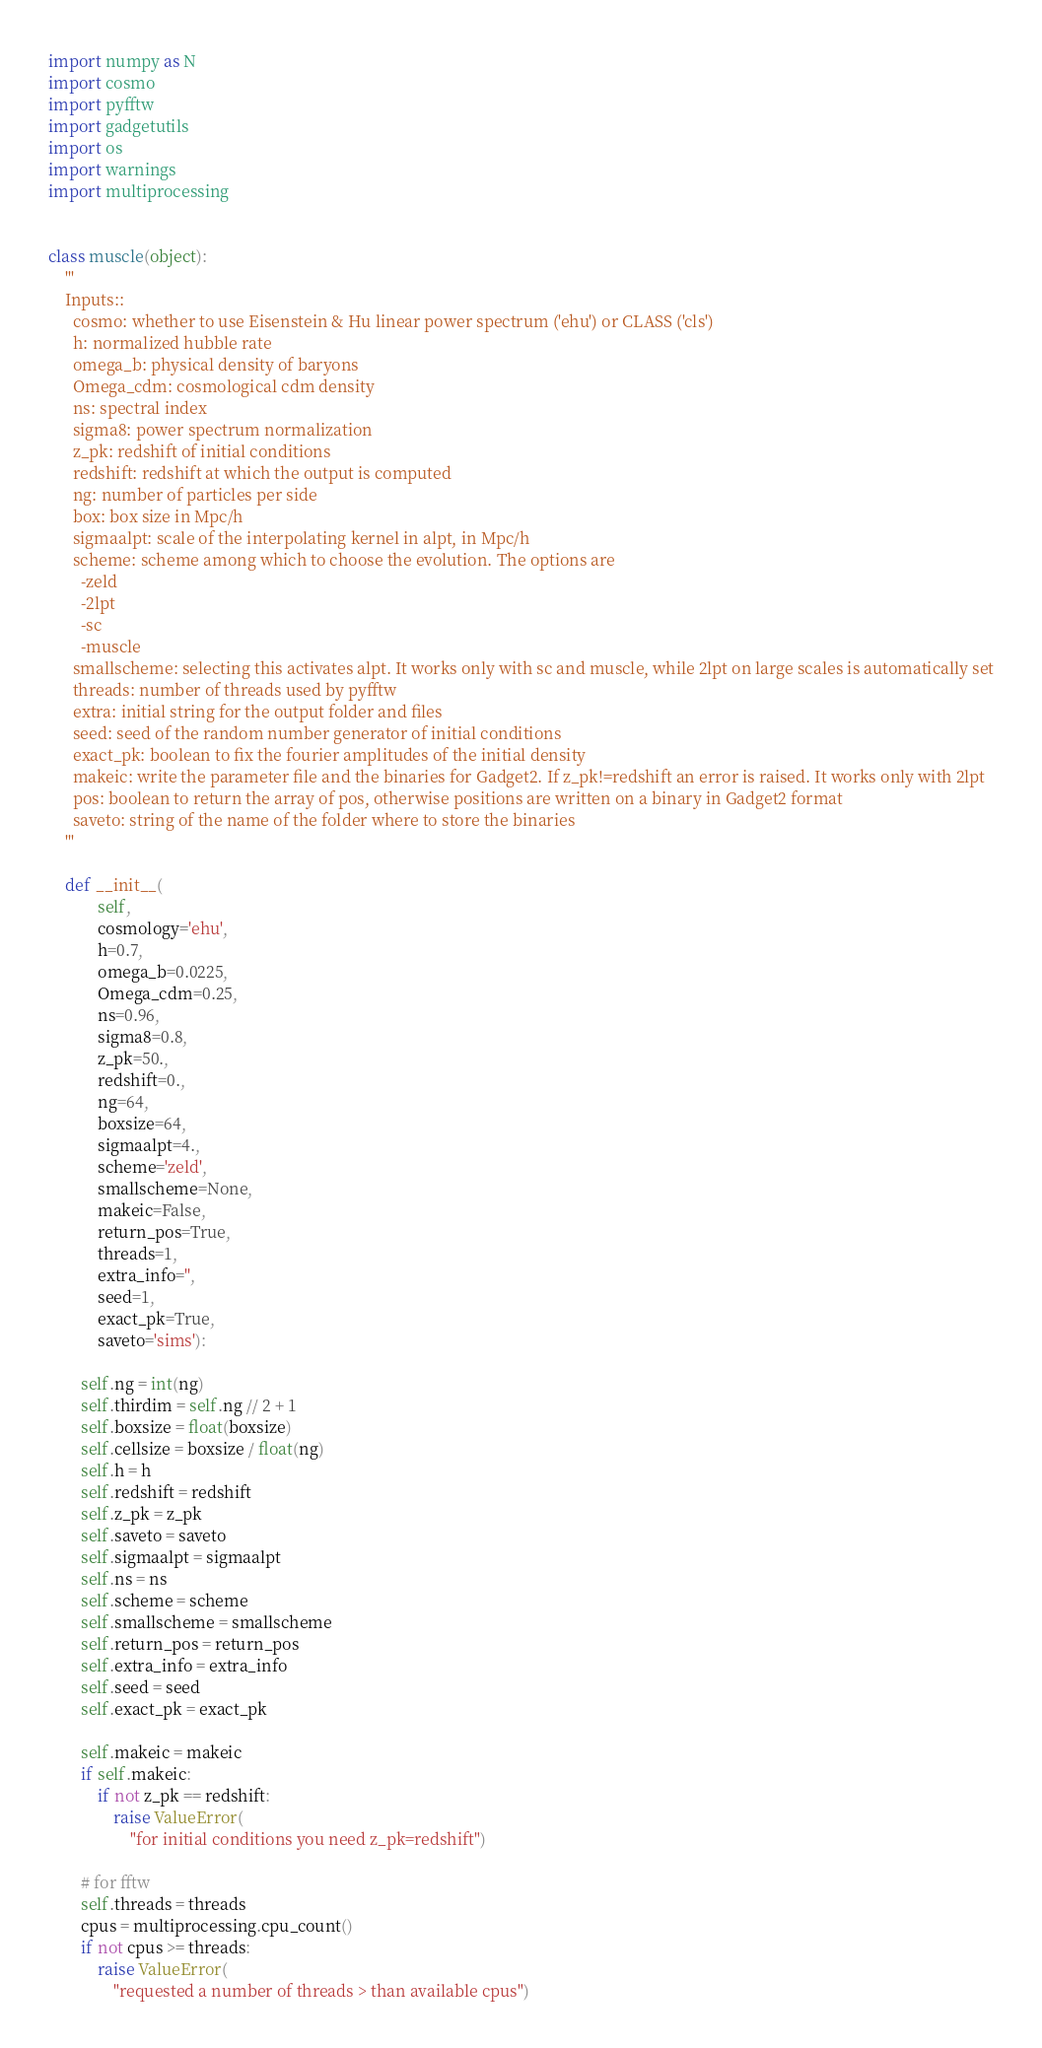<code> <loc_0><loc_0><loc_500><loc_500><_Python_>import numpy as N
import cosmo
import pyfftw
import gadgetutils
import os
import warnings
import multiprocessing


class muscle(object):
    '''
    Inputs::
      cosmo: whether to use Eisenstein & Hu linear power spectrum ('ehu') or CLASS ('cls')
      h: normalized hubble rate
      omega_b: physical density of baryons
      Omega_cdm: cosmological cdm density
      ns: spectral index
      sigma8: power spectrum normalization
      z_pk: redshift of initial conditions
      redshift: redshift at which the output is computed
      ng: number of particles per side
      box: box size in Mpc/h
      sigmaalpt: scale of the interpolating kernel in alpt, in Mpc/h
      scheme: scheme among which to choose the evolution. The options are
        -zeld
        -2lpt
        -sc
        -muscle
      smallscheme: selecting this activates alpt. It works only with sc and muscle, while 2lpt on large scales is automatically set
      threads: number of threads used by pyfftw
      extra: initial string for the output folder and files
      seed: seed of the random number generator of initial conditions
      exact_pk: boolean to fix the fourier amplitudes of the initial density
      makeic: write the parameter file and the binaries for Gadget2. If z_pk!=redshift an error is raised. It works only with 2lpt
      pos: boolean to return the array of pos, otherwise positions are written on a binary in Gadget2 format
      saveto: string of the name of the folder where to store the binaries
    '''

    def __init__(
            self,
            cosmology='ehu',
            h=0.7,
            omega_b=0.0225,
            Omega_cdm=0.25,
            ns=0.96,
            sigma8=0.8,
            z_pk=50.,
            redshift=0.,
            ng=64,
            boxsize=64,
            sigmaalpt=4.,
            scheme='zeld',
            smallscheme=None,
            makeic=False,
            return_pos=True,
            threads=1,
            extra_info='',
            seed=1,
            exact_pk=True,
            saveto='sims'):

        self.ng = int(ng)
        self.thirdim = self.ng // 2 + 1
        self.boxsize = float(boxsize)
        self.cellsize = boxsize / float(ng)
        self.h = h
        self.redshift = redshift
        self.z_pk = z_pk
        self.saveto = saveto
        self.sigmaalpt = sigmaalpt
        self.ns = ns
        self.scheme = scheme
        self.smallscheme = smallscheme
        self.return_pos = return_pos
        self.extra_info = extra_info
        self.seed = seed
        self.exact_pk = exact_pk

        self.makeic = makeic
        if self.makeic:
            if not z_pk == redshift:
                raise ValueError(
                    "for initial conditions you need z_pk=redshift")

        # for fftw
        self.threads = threads
        cpus = multiprocessing.cpu_count()
        if not cpus >= threads:
            raise ValueError(
                "requested a number of threads > than available cpus")
</code> 